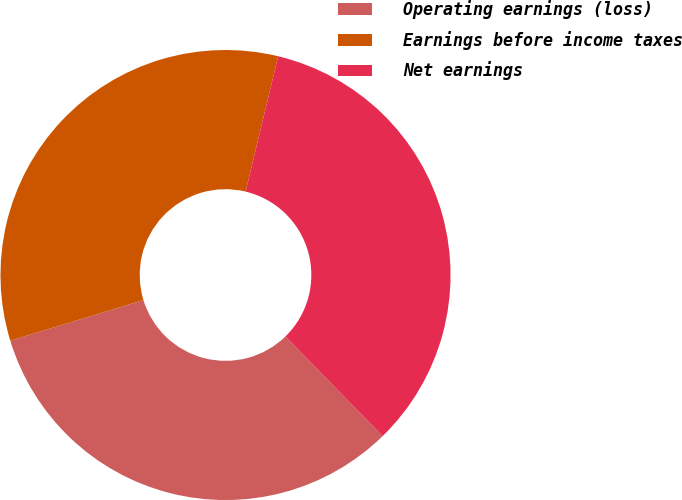<chart> <loc_0><loc_0><loc_500><loc_500><pie_chart><fcel>Operating earnings (loss)<fcel>Earnings before income taxes<fcel>Net earnings<nl><fcel>32.59%<fcel>33.47%<fcel>33.94%<nl></chart> 